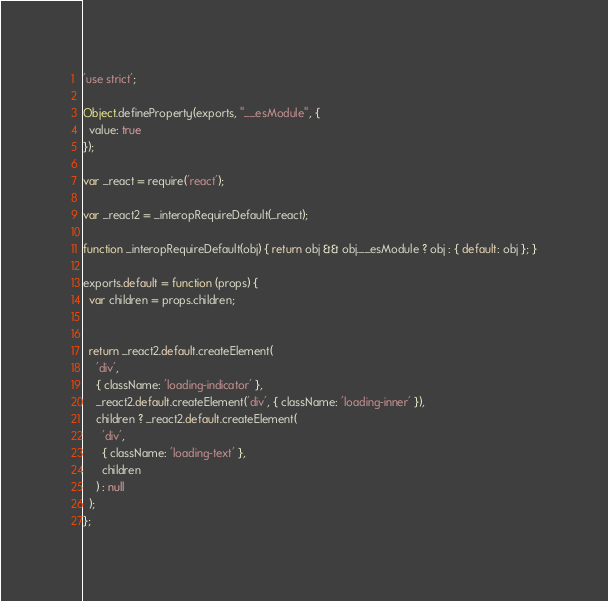Convert code to text. <code><loc_0><loc_0><loc_500><loc_500><_JavaScript_>'use strict';

Object.defineProperty(exports, "__esModule", {
  value: true
});

var _react = require('react');

var _react2 = _interopRequireDefault(_react);

function _interopRequireDefault(obj) { return obj && obj.__esModule ? obj : { default: obj }; }

exports.default = function (props) {
  var children = props.children;


  return _react2.default.createElement(
    'div',
    { className: 'loading-indicator' },
    _react2.default.createElement('div', { className: 'loading-inner' }),
    children ? _react2.default.createElement(
      'div',
      { className: 'loading-text' },
      children
    ) : null
  );
};</code> 